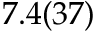<formula> <loc_0><loc_0><loc_500><loc_500>7 . 4 ( 3 7 )</formula> 